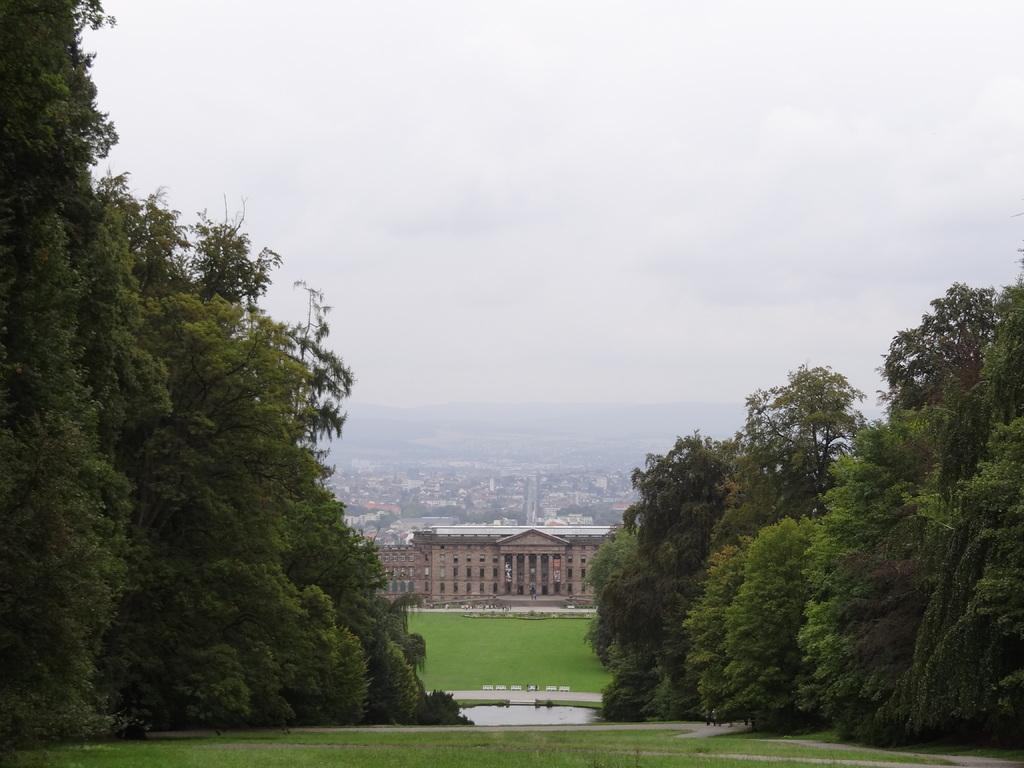What type of natural environment is visible in the image? There is grass and trees visible in the image, suggesting a natural setting. What type of water is visible in the image? There is water visible in the image, but the specific type of water (e.g., river, lake, pond) cannot be determined from the provided facts. What is visible in the background of the image? There is a building and the sky visible in the background of the image. What type of caption can be seen at the bottom of the image? There is no caption visible at the bottom of the image. What type of songs can be heard playing in the background of the image? There is no audio component to the image, so it is not possible to determine what type of songs might be heard. 